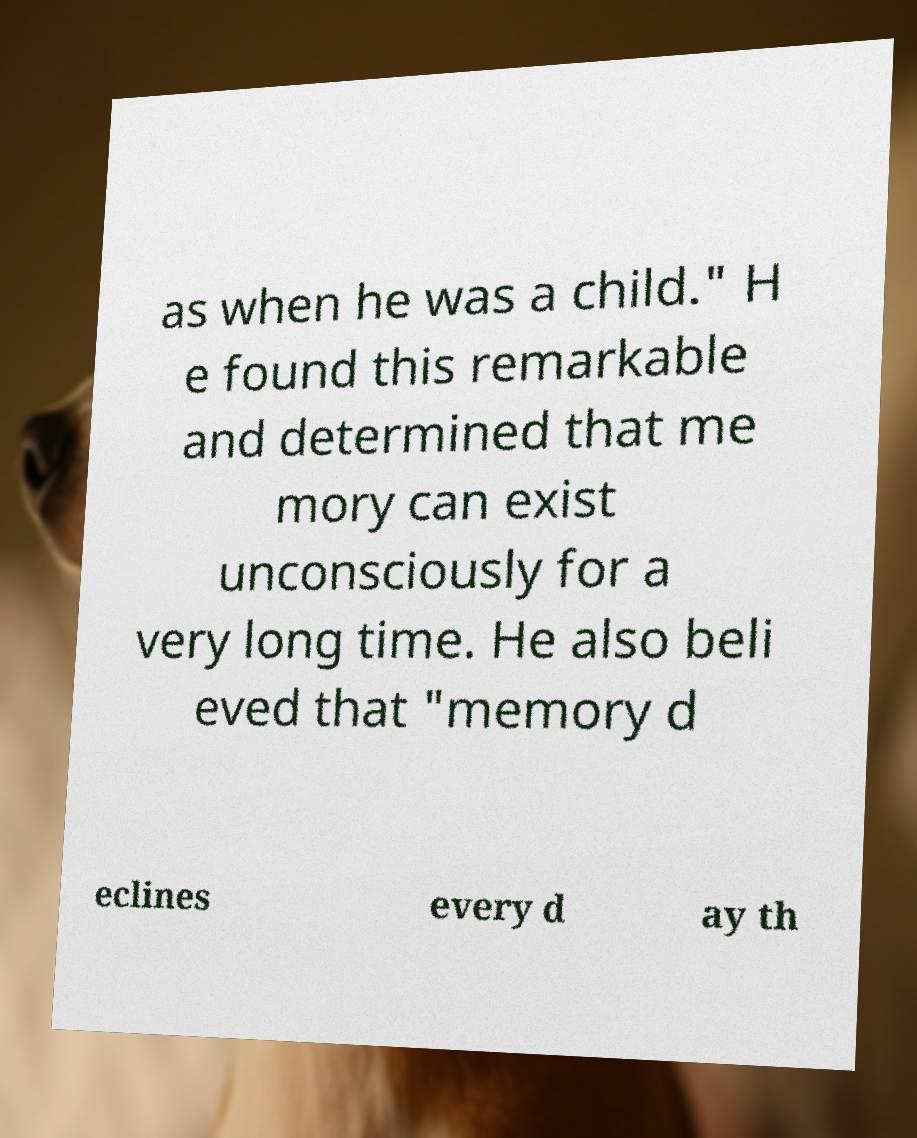Can you read and provide the text displayed in the image?This photo seems to have some interesting text. Can you extract and type it out for me? as when he was a child." H e found this remarkable and determined that me mory can exist unconsciously for a very long time. He also beli eved that "memory d eclines every d ay th 